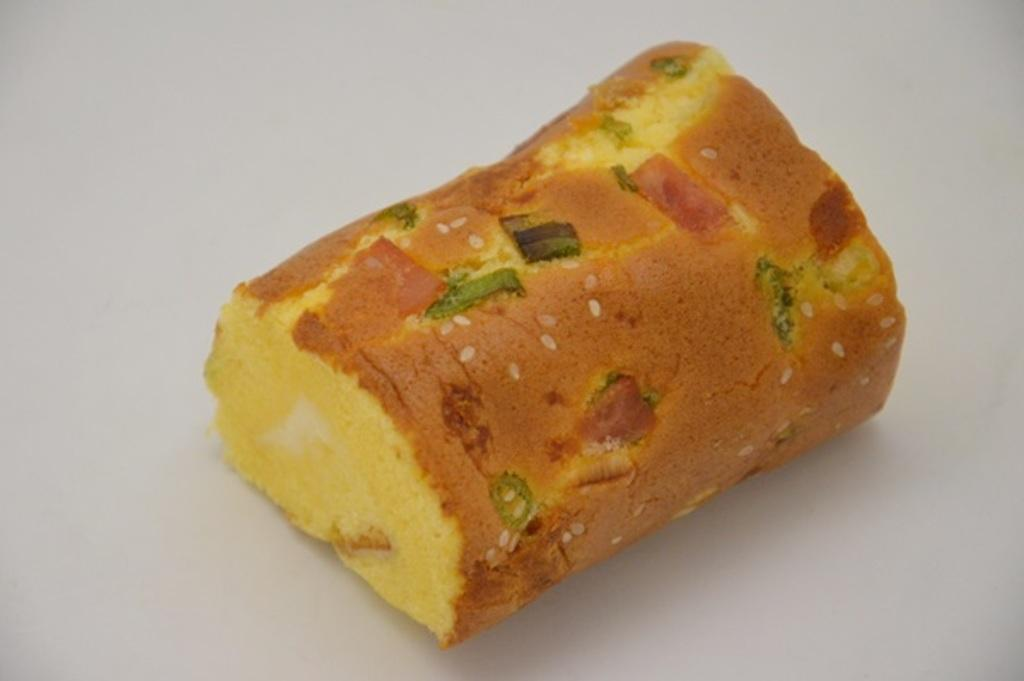What is the color of the food item in the image? The food item in the image has brown and yellow colors. What color is the background of the image? The background of the image is white. What type of theory is being discussed in the image? There is no discussion or theory present in the image; it features a food item with brown and yellow colors against a white background. 